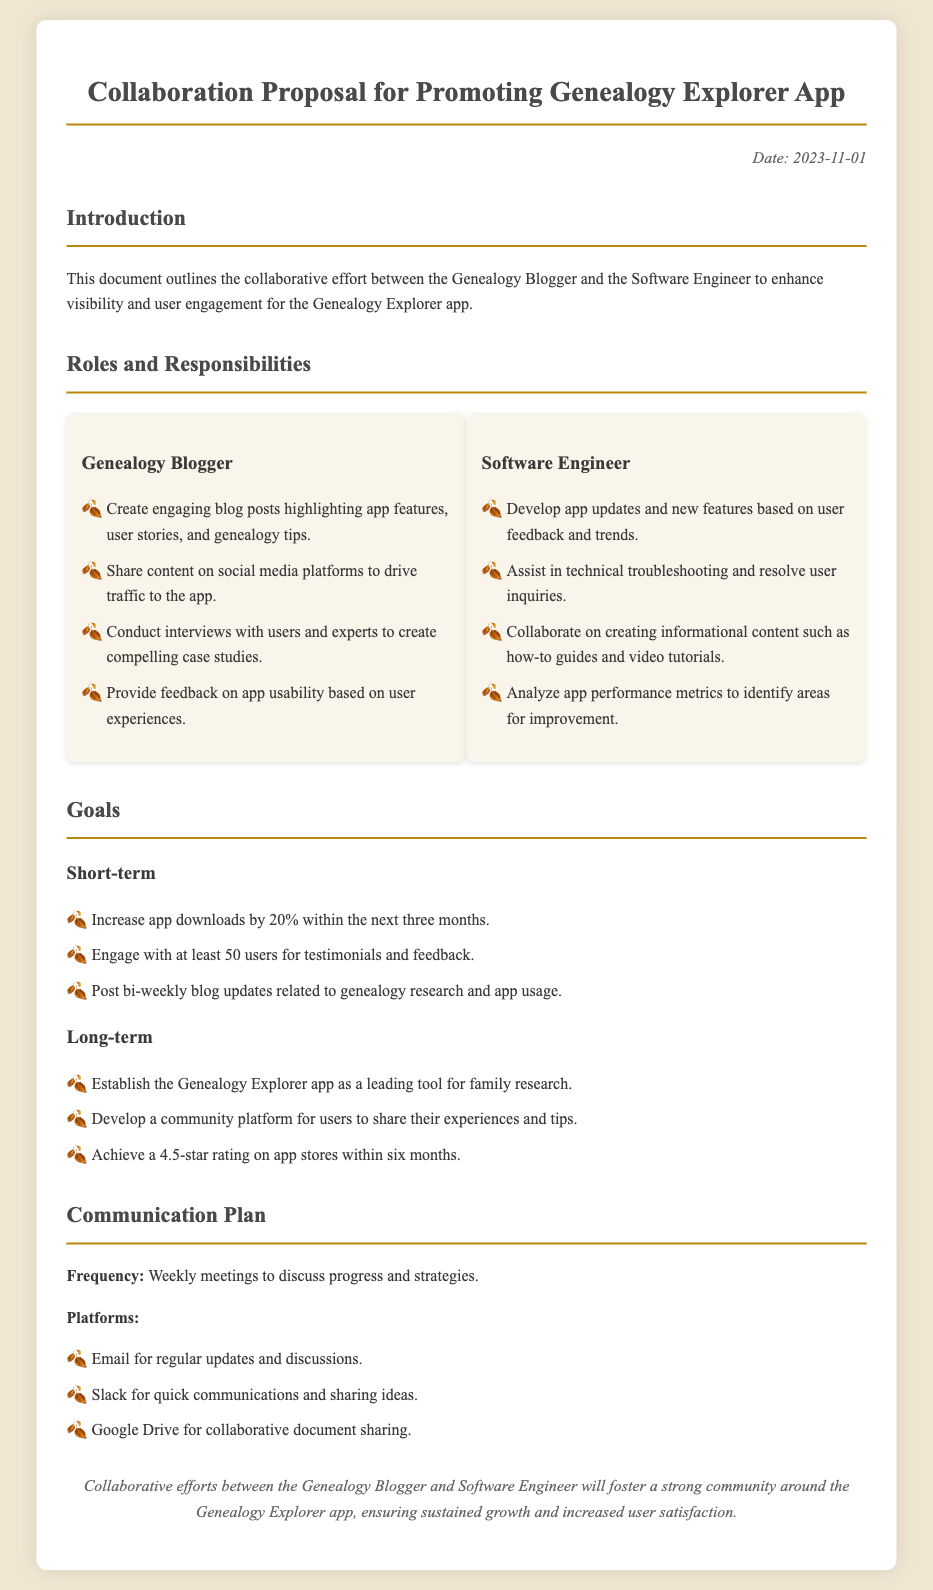what is the date of the document? The date is mentioned at the top right corner of the document.
Answer: 2023-11-01 what is the primary goal for the short-term? The primary short-term goal is outlined in the goals section, specifically focusing on app downloads.
Answer: Increase app downloads by 20% how often are blog updates expected to be posted? The frequency of blog updates is specified in the short-term goals to maintain engagement.
Answer: Bi-weekly who is responsible for creating blog posts? The roles section clearly identifies responsibilities assigned to each collaborator.
Answer: Genealogy Blogger what platform is suggested for quick communications? The document lists communication platforms and their purposes.
Answer: Slack what is the long-term goal regarding community development? The long-term goals include objectives related to user community engagement.
Answer: Develop a community platform how many users are targeted for testimonials in the short-term? The document specifies the engagement target in the short-term goals section.
Answer: 50 users what will be the frequency of meetings to discuss progress? The communication plan mentions how often meetings will be held to ensure ongoing collaboration.
Answer: Weekly meetings which role is tasked with analyzing app performance metrics? The responsibilities related to app performance analysis are outlined in the roles section.
Answer: Software Engineer 